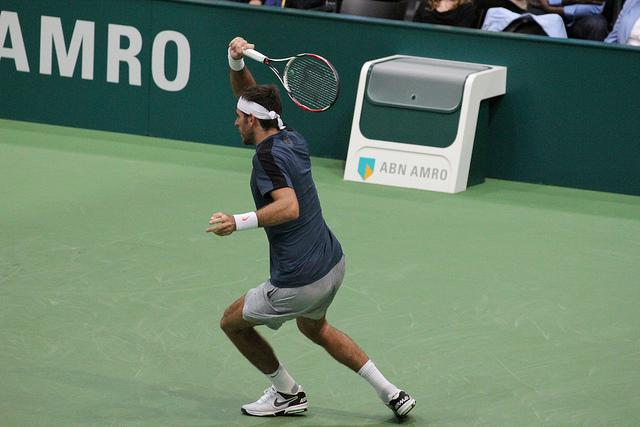What bank is a sponsor of the tennis event? Please explain your reasoning. abn amro. You can see the letters of the name on the items on the court 